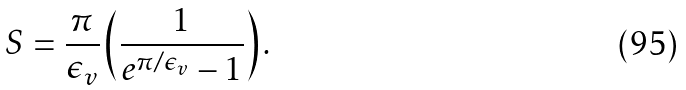<formula> <loc_0><loc_0><loc_500><loc_500>S = \frac { \pi } { \epsilon _ { v } } \left ( \frac { 1 } { e ^ { \pi / \epsilon _ { v } } - 1 } \right ) .</formula> 